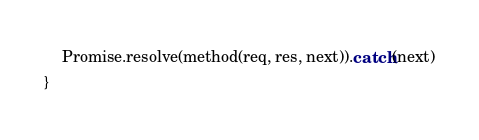<code> <loc_0><loc_0><loc_500><loc_500><_JavaScript_>    Promise.resolve(method(req, res, next)).catch(next)
}</code> 